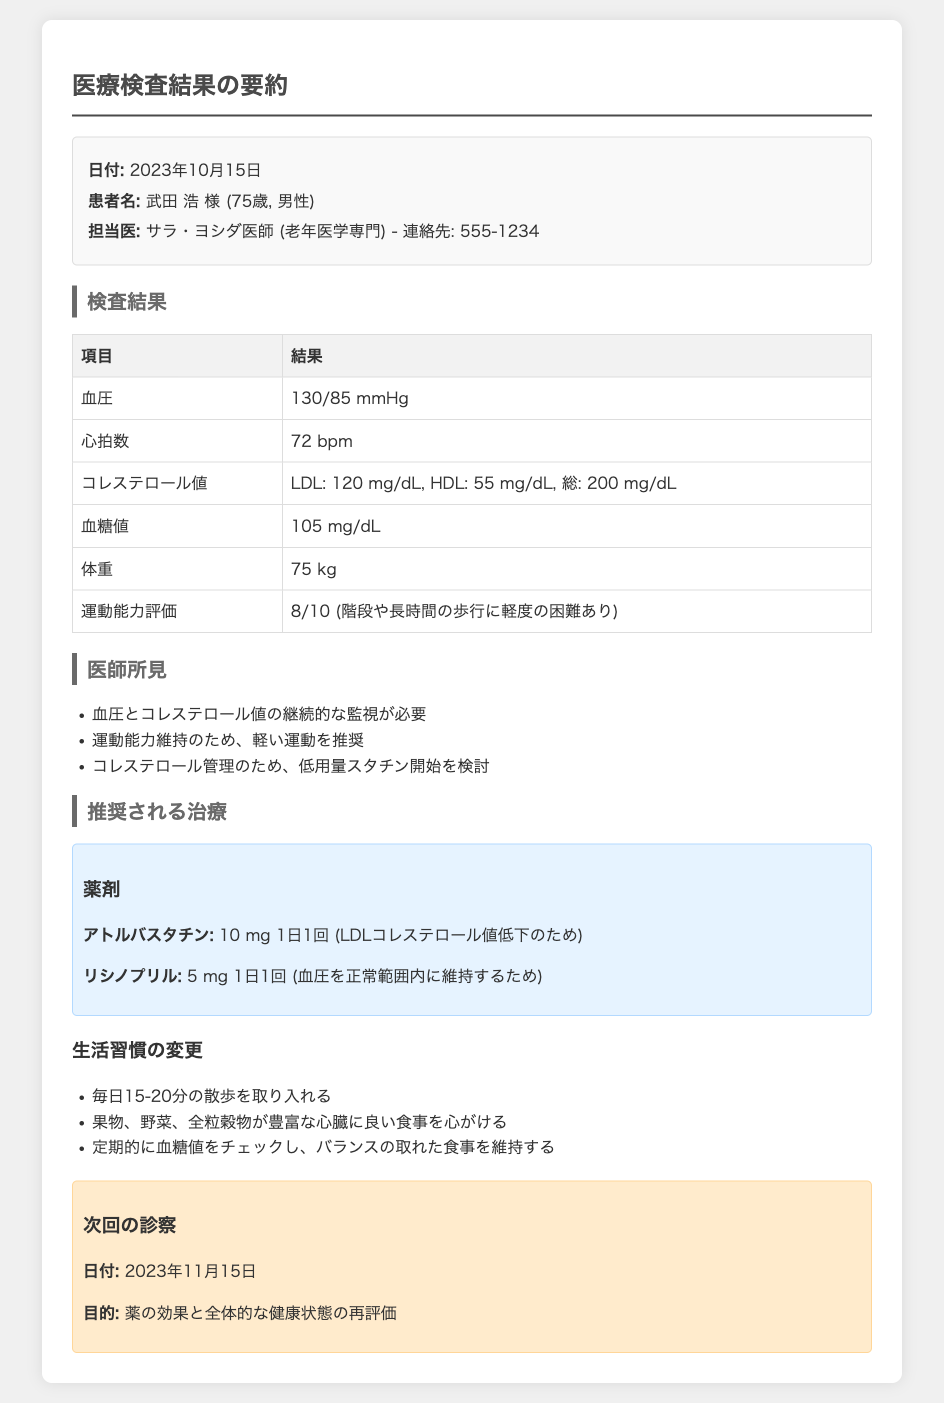日付はいつですか？ 日付は文書の最初に記載されており、2023年10月15日とあります。
Answer: 2023年10月15日 担当医の名前は誰ですか？ 担当医の情報は患者の詳細の部分にあり、サラ・ヨシダ医師と書かれています。
Answer: サラ・ヨシダ医師 血圧の結果は何ですか？ 検査結果の表に血圧が記載されており、130/85 mmHgとされています。
Answer: 130/85 mmHg 次回の診察日付はいつですか？ 次回の診察についての情報は文書の最後にあり、2023年11月15日と記載されています。
Answer: 2023年11月15日 アトルバスタチンの用量は？ 推奨される治療の薬剤セクションに具体的にアトルバスタチンの用量が書かれており、10 mg 1日1回と示されています。
Answer: 10 mg 1日1回 運動能力の評価点は何ですか？ 検査結果の表に運動能力評価が記載されており、8/10とされています。
Answer: 8/10 低用量スタチンについての医師の所見は？ 医師所見の部分には「コレステロール管理のため、低用量スタチン開始を検討」と書かれています。
Answer: 低用量スタチン開始を検討 生活習慣の変更には何が含まれていますか？ 生活習慣の変更のセクションに3つの提案があり、その一つが「毎日15-20分の散歩を取り入れる」とされている。
Answer: 毎日15-20分の散歩を取り入れる 